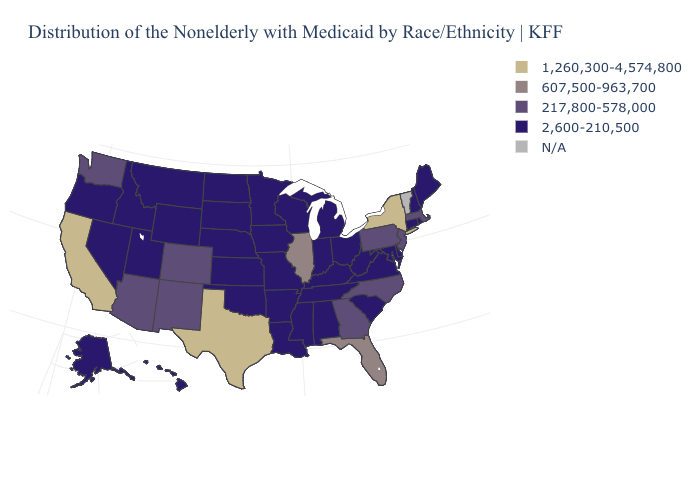Name the states that have a value in the range 2,600-210,500?
Be succinct. Alabama, Alaska, Arkansas, Connecticut, Delaware, Hawaii, Idaho, Indiana, Iowa, Kansas, Kentucky, Louisiana, Maine, Maryland, Michigan, Minnesota, Mississippi, Missouri, Montana, Nebraska, Nevada, New Hampshire, North Dakota, Ohio, Oklahoma, Oregon, Rhode Island, South Carolina, South Dakota, Tennessee, Utah, Virginia, West Virginia, Wisconsin, Wyoming. What is the value of Washington?
Quick response, please. 217,800-578,000. What is the value of Kansas?
Quick response, please. 2,600-210,500. Among the states that border North Carolina , which have the lowest value?
Concise answer only. South Carolina, Tennessee, Virginia. Does the first symbol in the legend represent the smallest category?
Be succinct. No. Does North Dakota have the lowest value in the MidWest?
Write a very short answer. Yes. What is the value of Missouri?
Quick response, please. 2,600-210,500. What is the value of North Carolina?
Short answer required. 217,800-578,000. What is the lowest value in states that border Ohio?
Short answer required. 2,600-210,500. Name the states that have a value in the range 2,600-210,500?
Give a very brief answer. Alabama, Alaska, Arkansas, Connecticut, Delaware, Hawaii, Idaho, Indiana, Iowa, Kansas, Kentucky, Louisiana, Maine, Maryland, Michigan, Minnesota, Mississippi, Missouri, Montana, Nebraska, Nevada, New Hampshire, North Dakota, Ohio, Oklahoma, Oregon, Rhode Island, South Carolina, South Dakota, Tennessee, Utah, Virginia, West Virginia, Wisconsin, Wyoming. Which states hav the highest value in the West?
Be succinct. California. Name the states that have a value in the range 1,260,300-4,574,800?
Short answer required. California, New York, Texas. Name the states that have a value in the range 2,600-210,500?
Be succinct. Alabama, Alaska, Arkansas, Connecticut, Delaware, Hawaii, Idaho, Indiana, Iowa, Kansas, Kentucky, Louisiana, Maine, Maryland, Michigan, Minnesota, Mississippi, Missouri, Montana, Nebraska, Nevada, New Hampshire, North Dakota, Ohio, Oklahoma, Oregon, Rhode Island, South Carolina, South Dakota, Tennessee, Utah, Virginia, West Virginia, Wisconsin, Wyoming. Name the states that have a value in the range 2,600-210,500?
Give a very brief answer. Alabama, Alaska, Arkansas, Connecticut, Delaware, Hawaii, Idaho, Indiana, Iowa, Kansas, Kentucky, Louisiana, Maine, Maryland, Michigan, Minnesota, Mississippi, Missouri, Montana, Nebraska, Nevada, New Hampshire, North Dakota, Ohio, Oklahoma, Oregon, Rhode Island, South Carolina, South Dakota, Tennessee, Utah, Virginia, West Virginia, Wisconsin, Wyoming. 